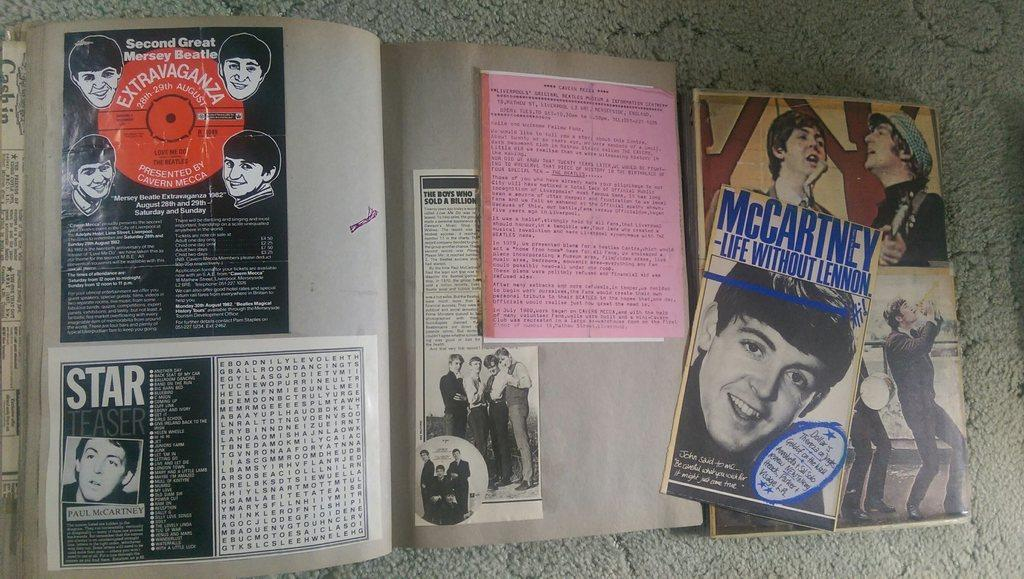<image>
Summarize the visual content of the image. A book of Beatles paraphernalia including an ad for McCartney - Life without Lennon. 